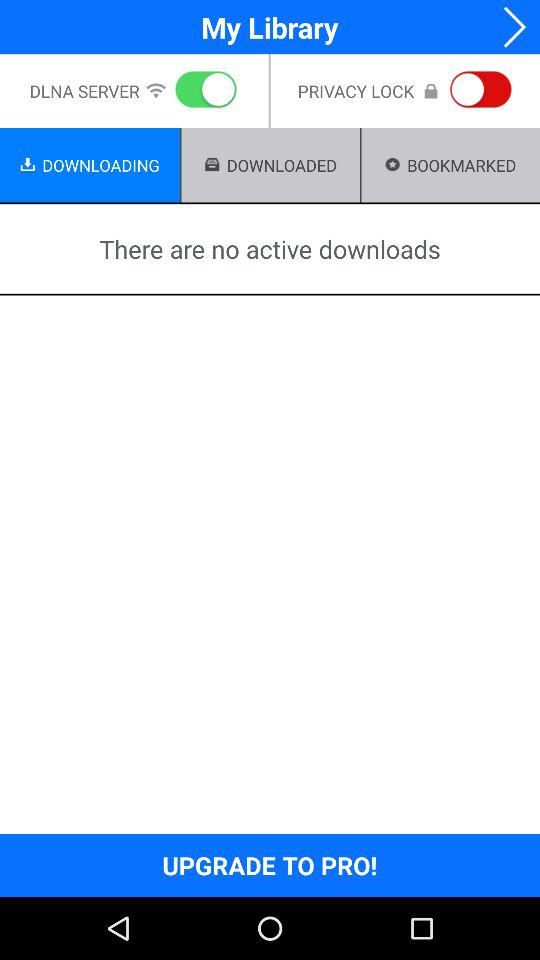What is the status of the "PRIVACY LOCK"? The status is "off". 